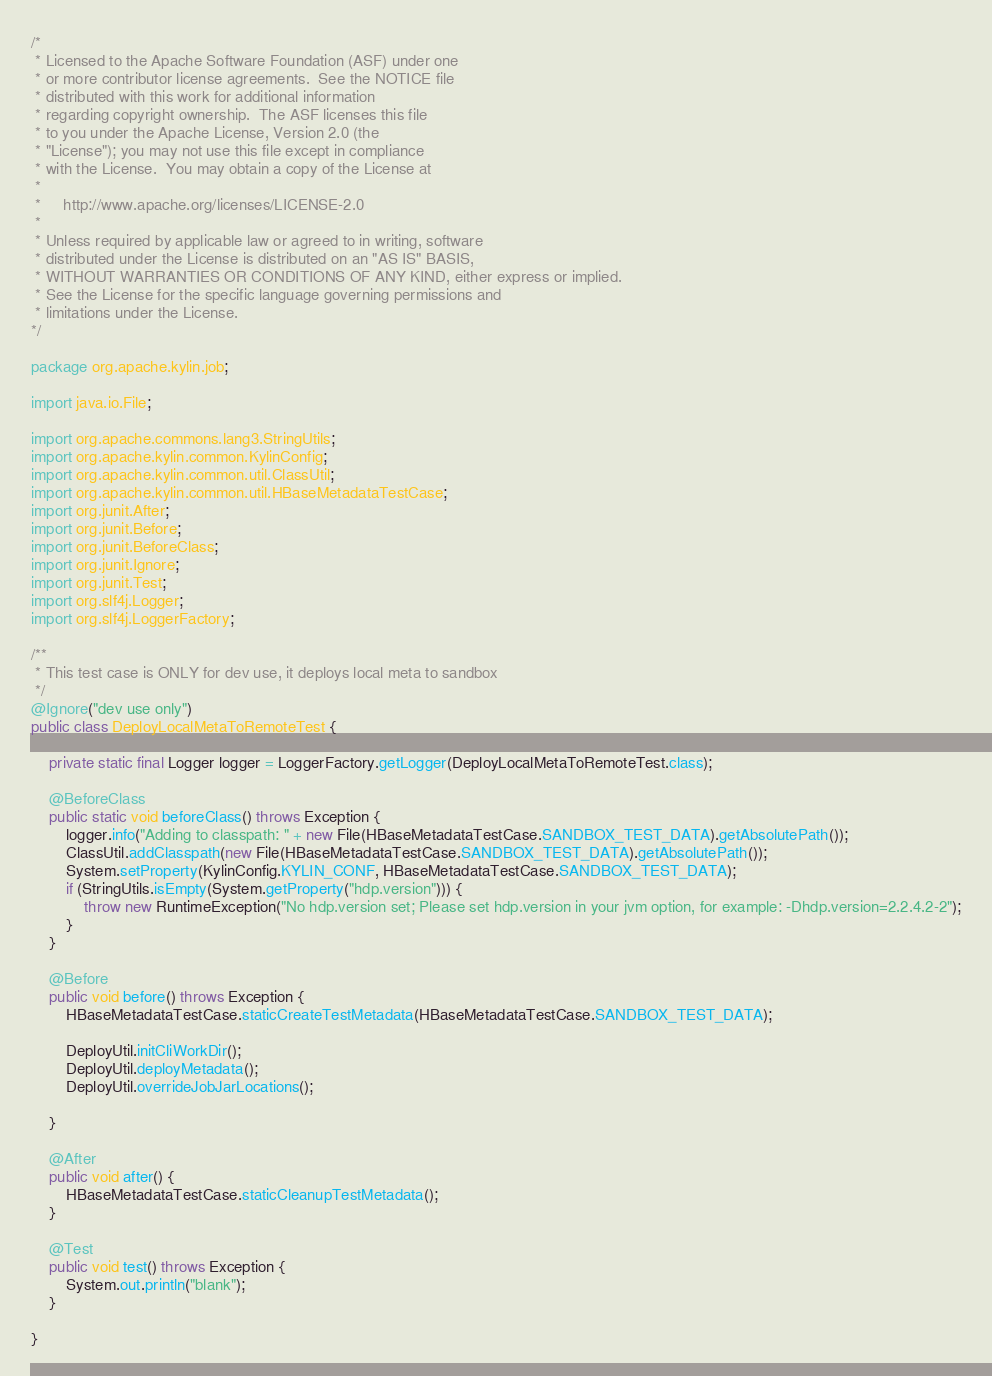<code> <loc_0><loc_0><loc_500><loc_500><_Java_>/*
 * Licensed to the Apache Software Foundation (ASF) under one
 * or more contributor license agreements.  See the NOTICE file
 * distributed with this work for additional information
 * regarding copyright ownership.  The ASF licenses this file
 * to you under the Apache License, Version 2.0 (the
 * "License"); you may not use this file except in compliance
 * with the License.  You may obtain a copy of the License at
 *
 *     http://www.apache.org/licenses/LICENSE-2.0
 *
 * Unless required by applicable law or agreed to in writing, software
 * distributed under the License is distributed on an "AS IS" BASIS,
 * WITHOUT WARRANTIES OR CONDITIONS OF ANY KIND, either express or implied.
 * See the License for the specific language governing permissions and
 * limitations under the License.
*/

package org.apache.kylin.job;

import java.io.File;

import org.apache.commons.lang3.StringUtils;
import org.apache.kylin.common.KylinConfig;
import org.apache.kylin.common.util.ClassUtil;
import org.apache.kylin.common.util.HBaseMetadataTestCase;
import org.junit.After;
import org.junit.Before;
import org.junit.BeforeClass;
import org.junit.Ignore;
import org.junit.Test;
import org.slf4j.Logger;
import org.slf4j.LoggerFactory;

/**
 * This test case is ONLY for dev use, it deploys local meta to sandbox
 */
@Ignore("dev use only")
public class DeployLocalMetaToRemoteTest {

    private static final Logger logger = LoggerFactory.getLogger(DeployLocalMetaToRemoteTest.class);

    @BeforeClass
    public static void beforeClass() throws Exception {
        logger.info("Adding to classpath: " + new File(HBaseMetadataTestCase.SANDBOX_TEST_DATA).getAbsolutePath());
        ClassUtil.addClasspath(new File(HBaseMetadataTestCase.SANDBOX_TEST_DATA).getAbsolutePath());
        System.setProperty(KylinConfig.KYLIN_CONF, HBaseMetadataTestCase.SANDBOX_TEST_DATA);
        if (StringUtils.isEmpty(System.getProperty("hdp.version"))) {
            throw new RuntimeException("No hdp.version set; Please set hdp.version in your jvm option, for example: -Dhdp.version=2.2.4.2-2");
        }
    }

    @Before
    public void before() throws Exception {
        HBaseMetadataTestCase.staticCreateTestMetadata(HBaseMetadataTestCase.SANDBOX_TEST_DATA);

        DeployUtil.initCliWorkDir();
        DeployUtil.deployMetadata();
        DeployUtil.overrideJobJarLocations();

    }

    @After
    public void after() {
        HBaseMetadataTestCase.staticCleanupTestMetadata();
    }

    @Test
    public void test() throws Exception {
        System.out.println("blank");
    }

}</code> 